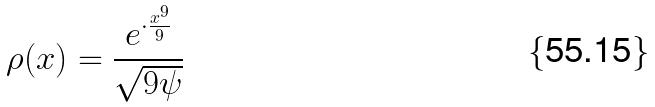<formula> <loc_0><loc_0><loc_500><loc_500>\rho ( x ) = \frac { e ^ { \cdot \frac { x ^ { 9 } } { 9 } } } { \sqrt { 9 \psi } }</formula> 